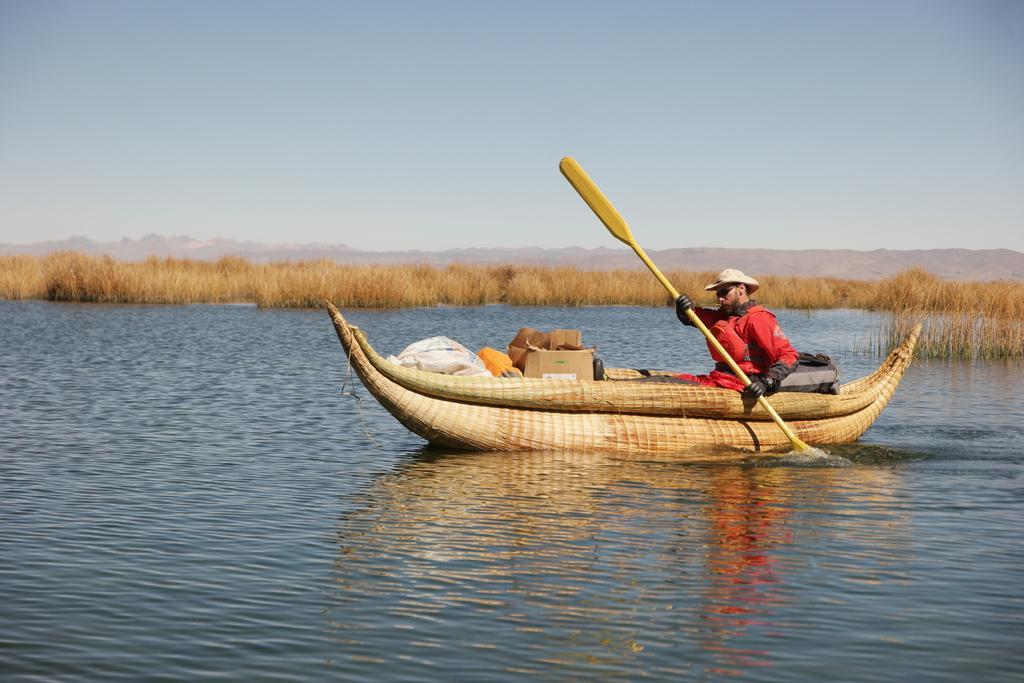Could you give a brief overview of what you see in this image? In this picture there is a boat in the center of the image on the water and there is a man in the boat, by holding an oar in his hands and there are boxes and a sack in the boat, there is dried grass in the background area of the mage. 